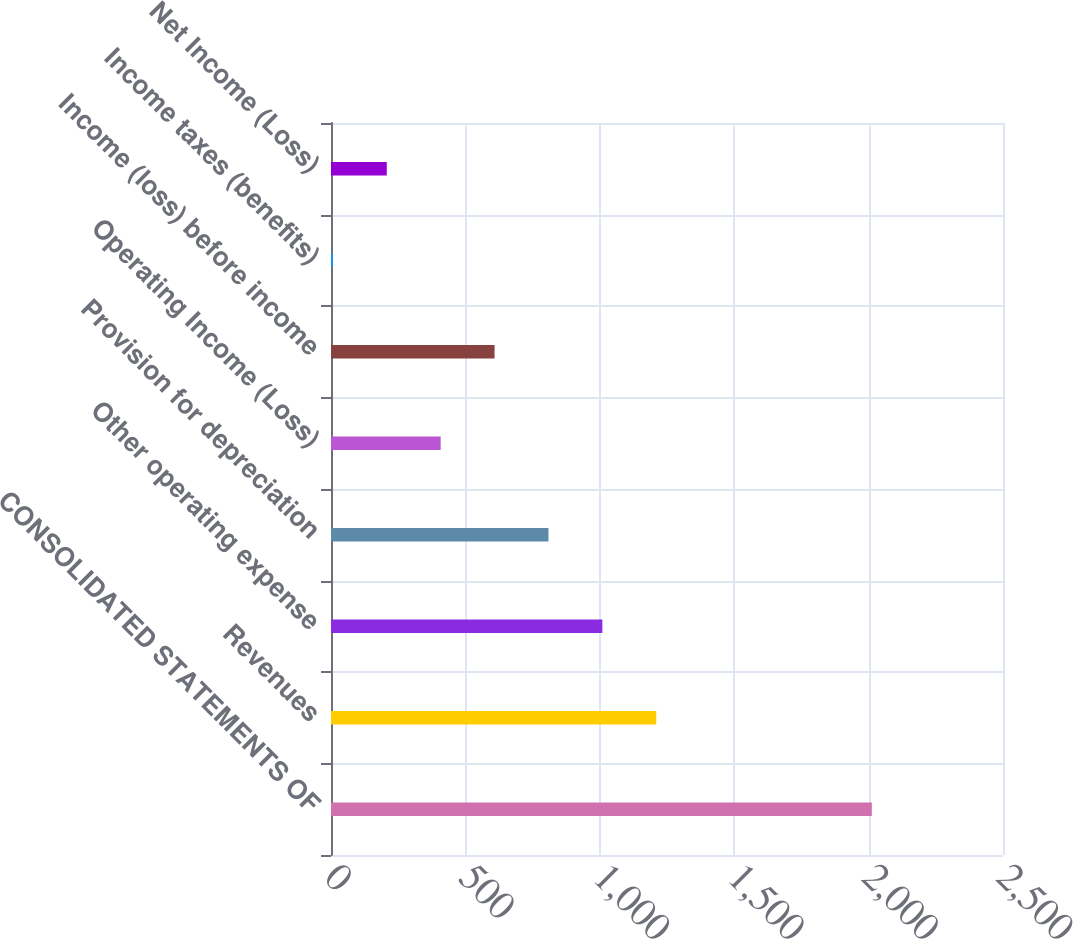<chart> <loc_0><loc_0><loc_500><loc_500><bar_chart><fcel>CONSOLIDATED STATEMENTS OF<fcel>Revenues<fcel>Other operating expense<fcel>Provision for depreciation<fcel>Operating Income (Loss)<fcel>Income (loss) before income<fcel>Income taxes (benefits)<fcel>Net Income (Loss)<nl><fcel>2012<fcel>1210<fcel>1009.5<fcel>809<fcel>408<fcel>608.5<fcel>7<fcel>207.5<nl></chart> 